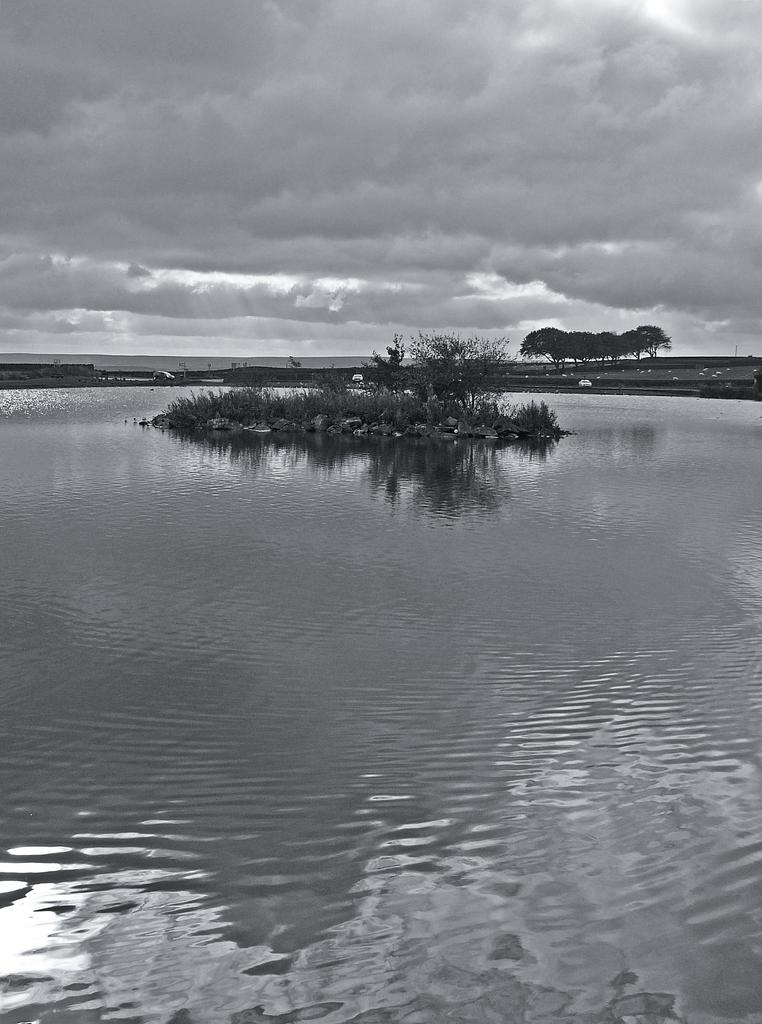What is the primary element visible in the image? There is water in the image. What types of vegetation can be seen in the image? There are plants and trees in the image. What can be seen in the background of the image? In the background of the image, there are trees, cars, and other objects. What part of the natural environment is visible in the image? The sky is visible in the background of the image. What is the weather like in the image? Clouds are present in the sky, indicating that it might be partly cloudy. What is the chance of the plants walking away in the image? Plants do not have the ability to walk, so there is no chance of them walking away in the image. 